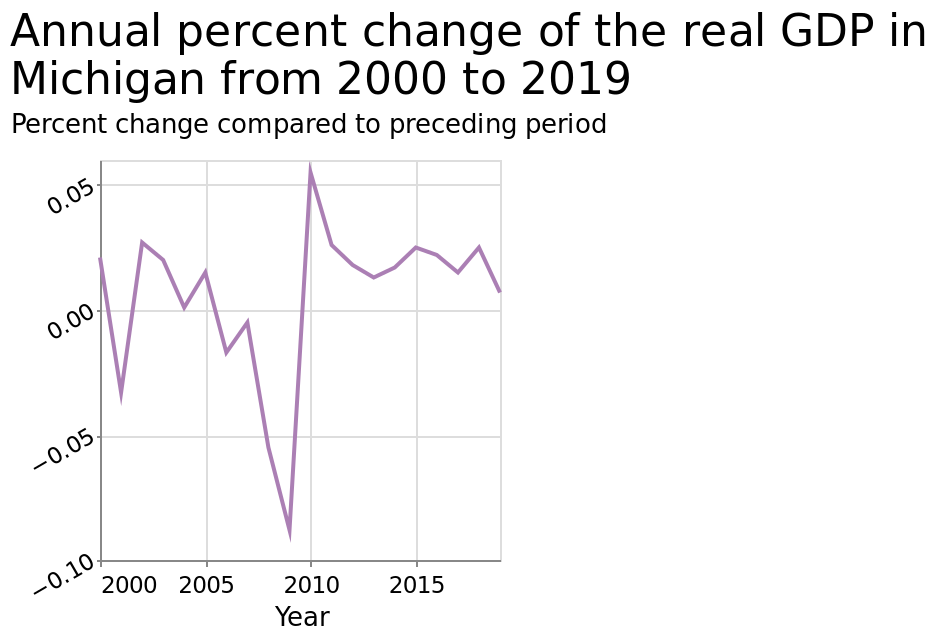<image>
In which year did Michigan experience the greatest increase in GDP? The greatest increase in Michigan GDP was in 2010. What happened to Michigan GDP in 2009? There was a sharp decrease in Michigan GDP in 2009. 